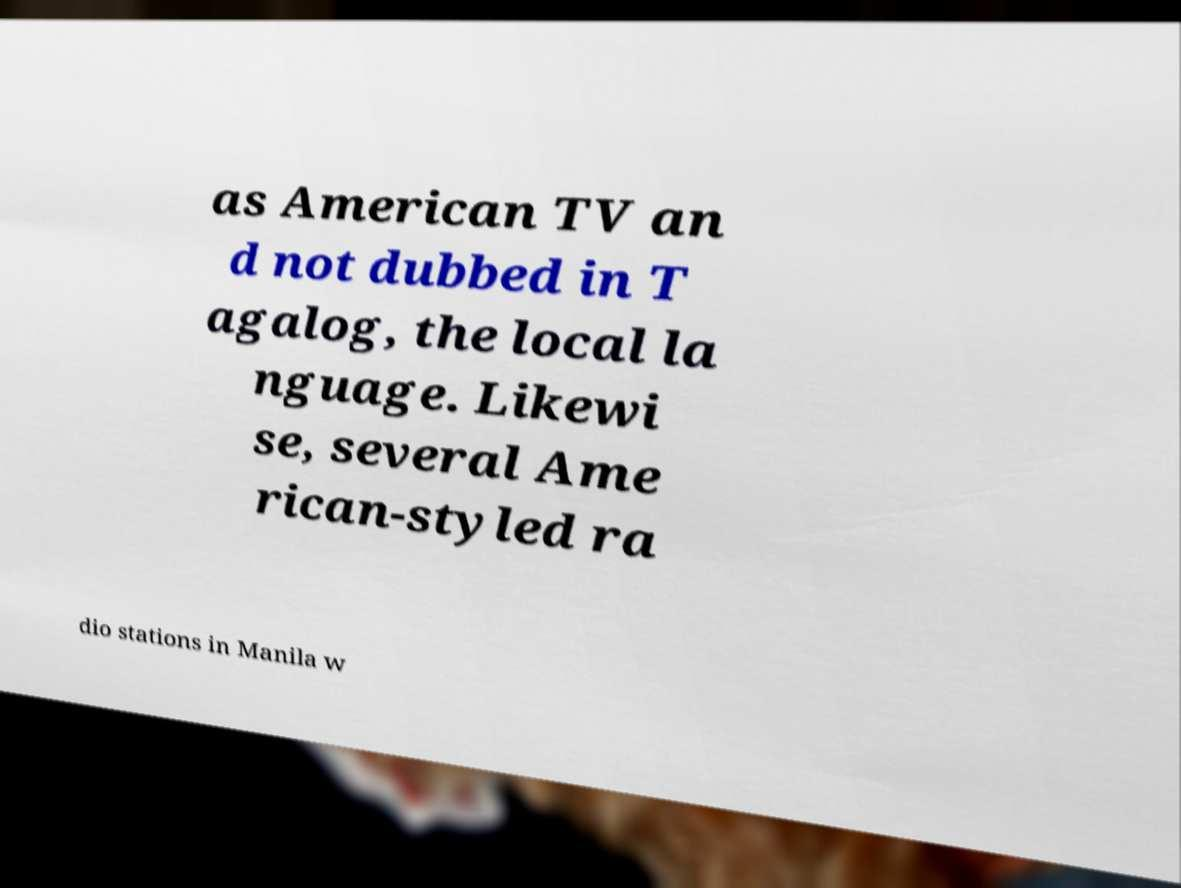Please identify and transcribe the text found in this image. as American TV an d not dubbed in T agalog, the local la nguage. Likewi se, several Ame rican-styled ra dio stations in Manila w 